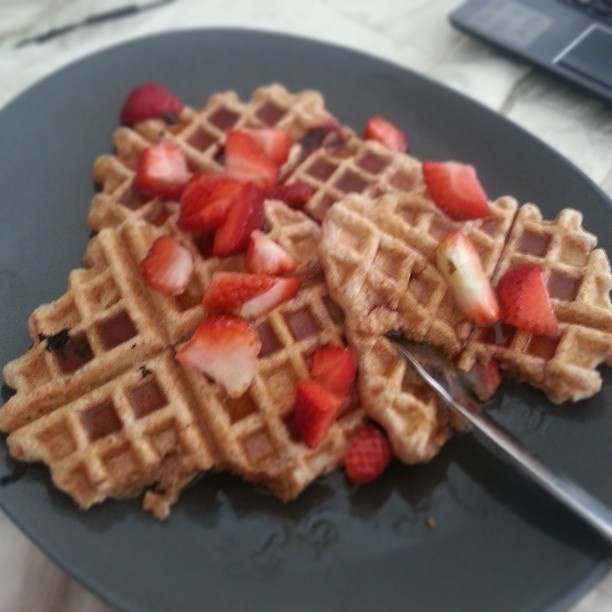Describe the objects in this image and their specific colors. I can see dining table in gray, brown, black, maroon, and lightgray tones, cake in darkgray, brown, maroon, and tan tones, laptop in darkgray and gray tones, and knife in darkgray, gray, maroon, and black tones in this image. 